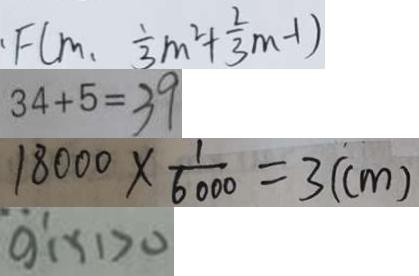<formula> <loc_0><loc_0><loc_500><loc_500>F ( m , \frac { 1 } { 3 } m ^ { 2 } + \frac { 2 } { 3 } m - 1 ) 
 3 4 + 5 = 3 9 
 1 8 0 0 0 \times \frac { 1 } { 6 0 0 0 } = 3 ( c m ) 
 g ^ { \prime } ( x ) > 0</formula> 